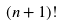Convert formula to latex. <formula><loc_0><loc_0><loc_500><loc_500>( n + 1 ) !</formula> 